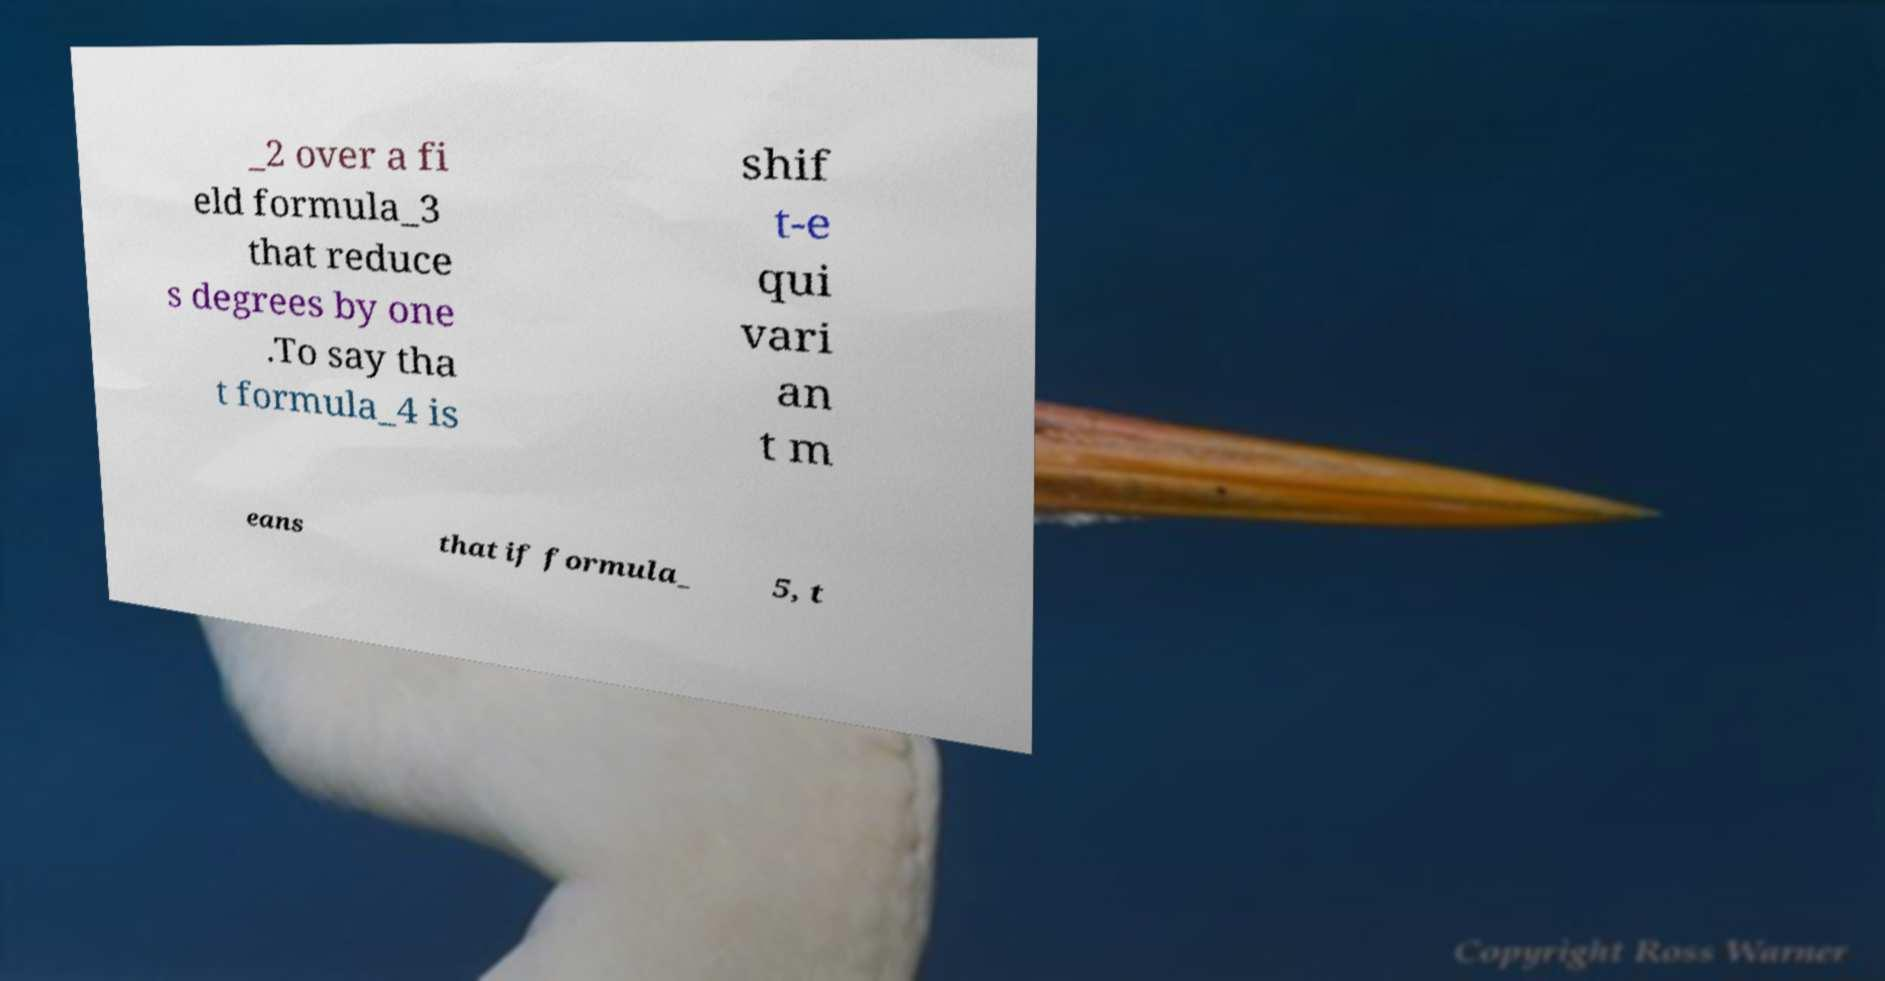Please identify and transcribe the text found in this image. _2 over a fi eld formula_3 that reduce s degrees by one .To say tha t formula_4 is shif t-e qui vari an t m eans that if formula_ 5, t 